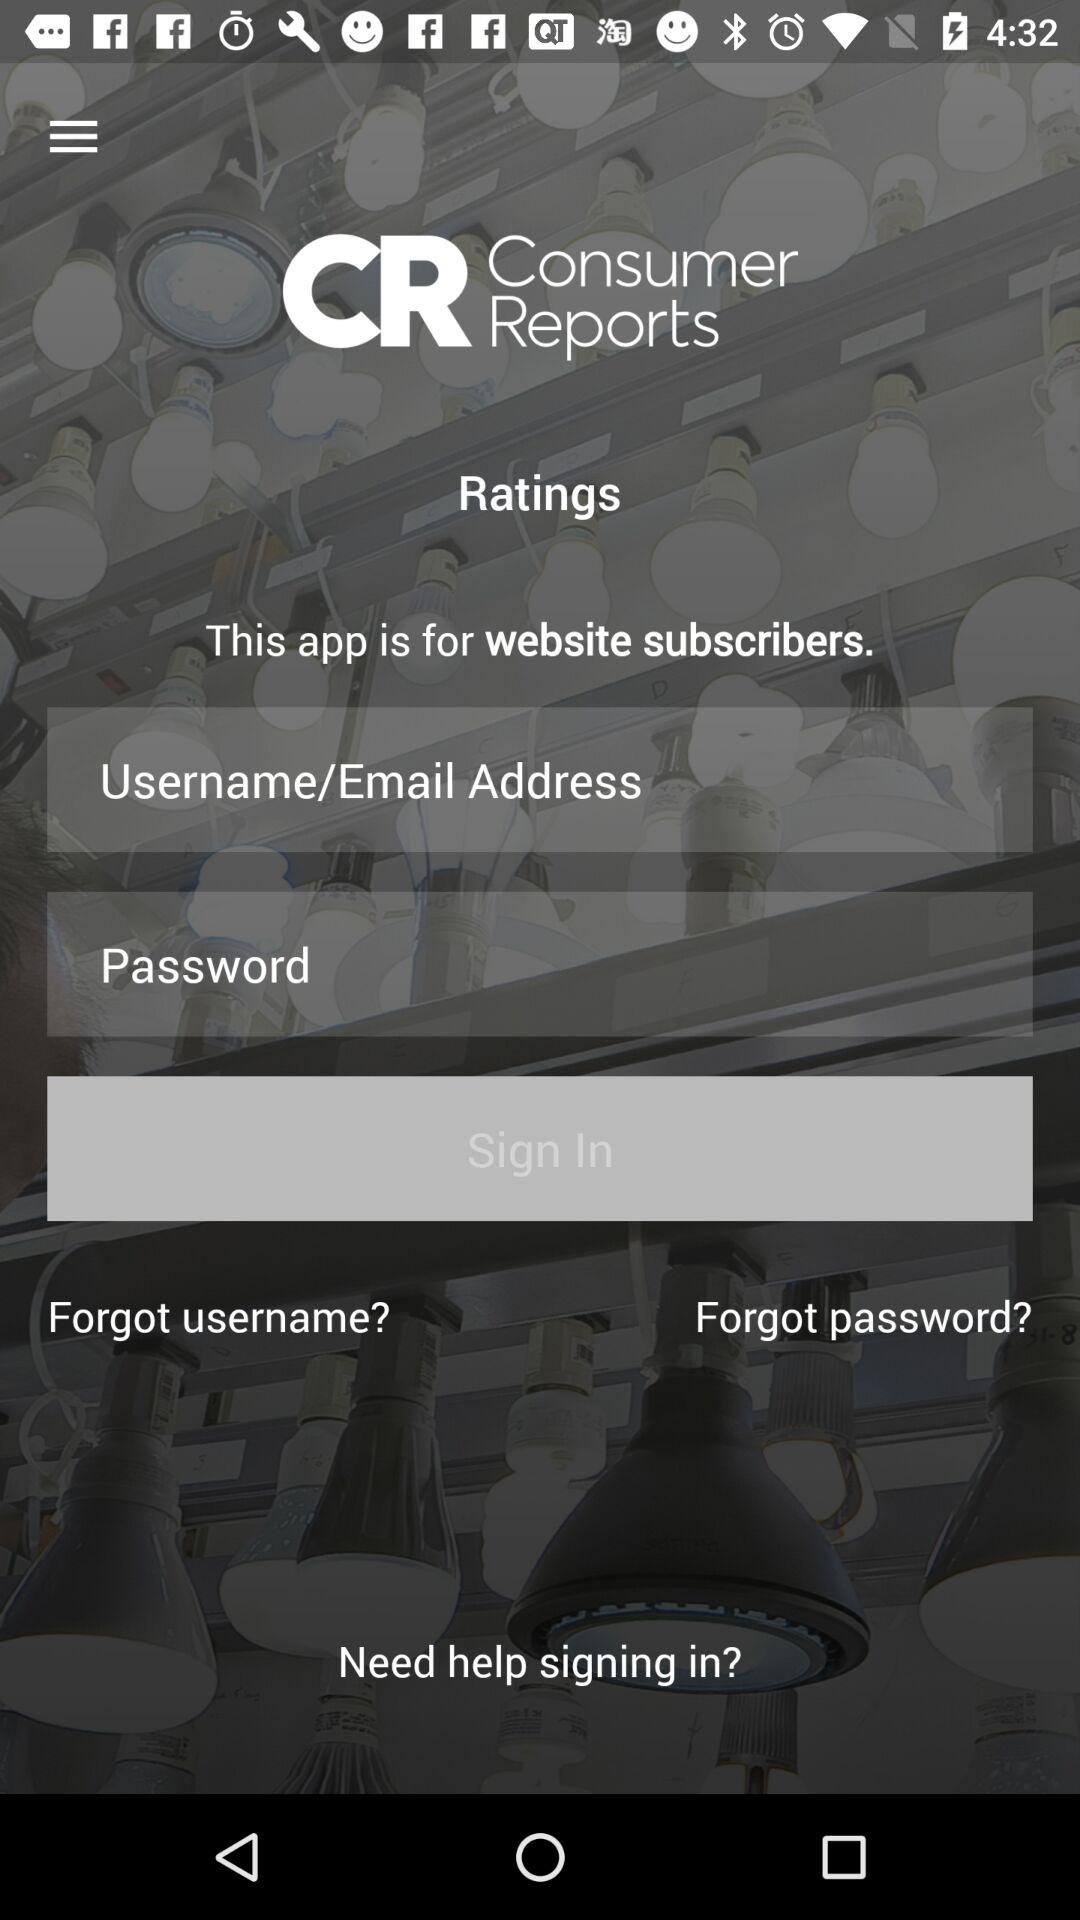How many text inputs are in the sign-in form? 2 